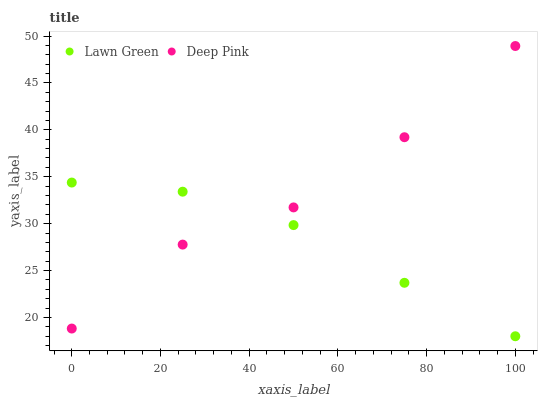Does Lawn Green have the minimum area under the curve?
Answer yes or no. Yes. Does Deep Pink have the maximum area under the curve?
Answer yes or no. Yes. Does Deep Pink have the minimum area under the curve?
Answer yes or no. No. Is Lawn Green the smoothest?
Answer yes or no. Yes. Is Deep Pink the roughest?
Answer yes or no. Yes. Is Deep Pink the smoothest?
Answer yes or no. No. Does Lawn Green have the lowest value?
Answer yes or no. Yes. Does Deep Pink have the lowest value?
Answer yes or no. No. Does Deep Pink have the highest value?
Answer yes or no. Yes. Does Deep Pink intersect Lawn Green?
Answer yes or no. Yes. Is Deep Pink less than Lawn Green?
Answer yes or no. No. Is Deep Pink greater than Lawn Green?
Answer yes or no. No. 